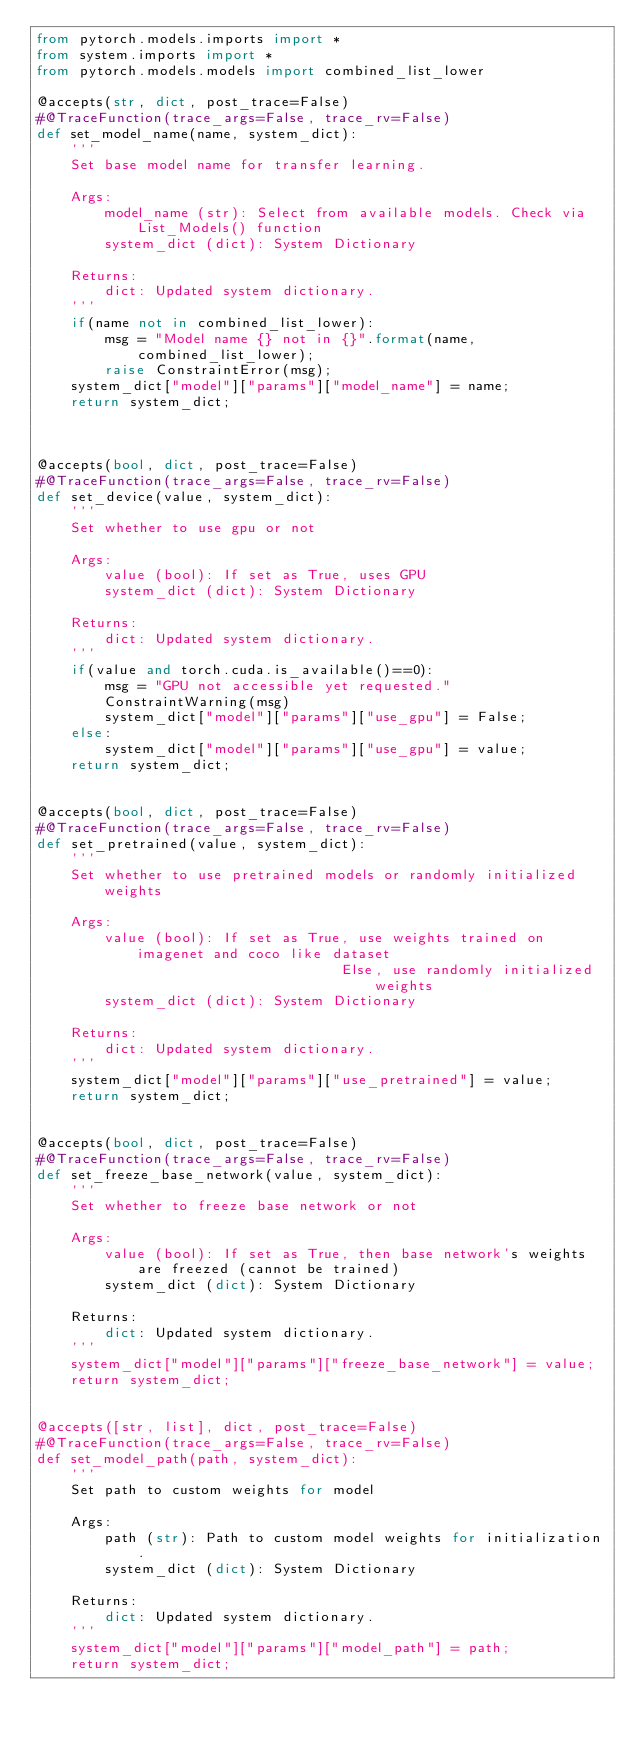Convert code to text. <code><loc_0><loc_0><loc_500><loc_500><_Python_>from pytorch.models.imports import *
from system.imports import *
from pytorch.models.models import combined_list_lower

@accepts(str, dict, post_trace=False)
#@TraceFunction(trace_args=False, trace_rv=False)
def set_model_name(name, system_dict):
    '''
    Set base model name for transfer learning.

    Args:
        model_name (str): Select from available models. Check via List_Models() function
        system_dict (dict): System Dictionary

    Returns:
        dict: Updated system dictionary.
    '''
    if(name not in combined_list_lower):
        msg = "Model name {} not in {}".format(name, combined_list_lower);
        raise ConstraintError(msg);
    system_dict["model"]["params"]["model_name"] = name;
    return system_dict;



@accepts(bool, dict, post_trace=False)
#@TraceFunction(trace_args=False, trace_rv=False)
def set_device(value, system_dict):
    '''
    Set whether to use gpu or not

    Args:
        value (bool): If set as True, uses GPU
        system_dict (dict): System Dictionary

    Returns:
        dict: Updated system dictionary.
    '''
    if(value and torch.cuda.is_available()==0):
        msg = "GPU not accessible yet requested."
        ConstraintWarning(msg)
        system_dict["model"]["params"]["use_gpu"] = False;
    else:
        system_dict["model"]["params"]["use_gpu"] = value;
    return system_dict;


@accepts(bool, dict, post_trace=False)
#@TraceFunction(trace_args=False, trace_rv=False)
def set_pretrained(value, system_dict):
    '''
    Set whether to use pretrained models or randomly initialized weights

    Args:
        value (bool): If set as True, use weights trained on imagenet and coco like dataset
                                    Else, use randomly initialized weights
        system_dict (dict): System Dictionary

    Returns:
        dict: Updated system dictionary.
    '''
    system_dict["model"]["params"]["use_pretrained"] = value;
    return system_dict;


@accepts(bool, dict, post_trace=False)
#@TraceFunction(trace_args=False, trace_rv=False)
def set_freeze_base_network(value, system_dict):
    '''
    Set whether to freeze base network or not

    Args:
        value (bool): If set as True, then base network's weights are freezed (cannot be trained)
        system_dict (dict): System Dictionary

    Returns:
        dict: Updated system dictionary.
    '''
    system_dict["model"]["params"]["freeze_base_network"] = value;
    return system_dict;


@accepts([str, list], dict, post_trace=False)
#@TraceFunction(trace_args=False, trace_rv=False)
def set_model_path(path, system_dict):
    '''
    Set path to custom weights for model

    Args:
        path (str): Path to custom model weights for initialization.
        system_dict (dict): System Dictionary
        
    Returns:
        dict: Updated system dictionary.
    '''
    system_dict["model"]["params"]["model_path"] = path;
    return system_dict;</code> 